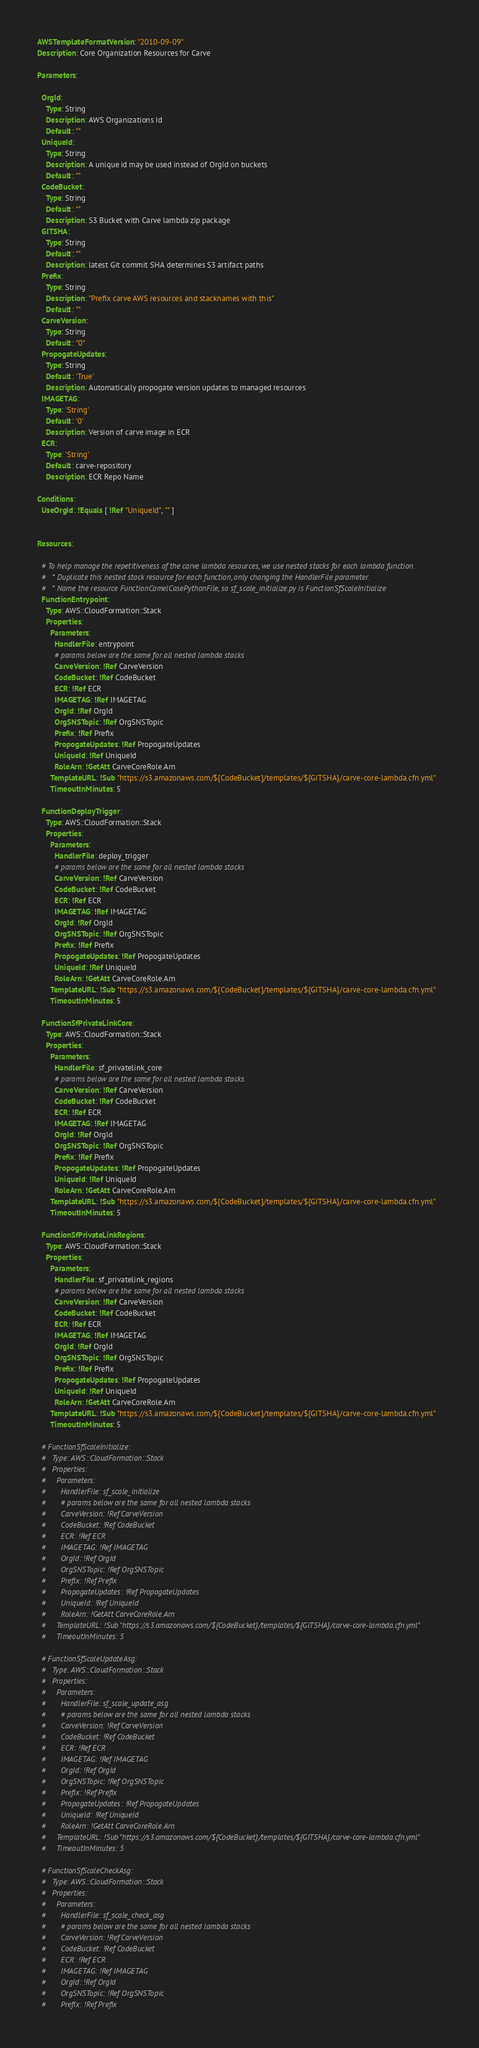<code> <loc_0><loc_0><loc_500><loc_500><_YAML_>AWSTemplateFormatVersion: "2010-09-09"
Description: Core Organization Resources for Carve

Parameters:
  
  OrgId:
    Type: String
    Description: AWS Organizations Id
    Default: ""
  UniqueId:
    Type: String
    Description: A unique id may be used instead of OrgId on buckets
    Default: ""
  CodeBucket:
    Type: String
    Default: ""
    Description: S3 Bucket with Carve lambda zip package
  GITSHA:
    Type: String
    Default: ""
    Description: latest Git commit SHA determines S3 artifact paths
  Prefix:
    Type: String
    Description: "Prefix carve AWS resources and stacknames with this"
    Default: ""
  CarveVersion:
    Type: String
    Default: "0"
  PropogateUpdates:
    Type: String
    Default: 'True'
    Description: Automatically propogate version updates to managed resources 
  IMAGETAG: 
    Type: 'String'
    Default: '0'
    Description: Version of carve image in ECR
  ECR:
    Type: 'String'
    Default: carve-repository
    Description: ECR Repo Name

Conditions:
  UseOrgId: !Equals [ !Ref "UniqueId", "" ]


Resources:

  # To help manage the repetitiveness of the carve lambda resources, we use nested stacks for each lambda function.
  #   * Duplicate this nested stack resource for each function, only changing the HandlerFile parameter.
  #   * Name the resource FunctionCamelCasePythonFile, so sf_scale_initialize.py is FunctionSfScaleInitialize
  FunctionEntrypoint:
    Type: AWS::CloudFormation::Stack
    Properties: 
      Parameters:
        HandlerFile: entrypoint
        # params below are the same for all nested lambda stacks
        CarveVersion: !Ref CarveVersion
        CodeBucket: !Ref CodeBucket
        ECR: !Ref ECR
        IMAGETAG: !Ref IMAGETAG
        OrgId: !Ref OrgId
        OrgSNSTopic: !Ref OrgSNSTopic
        Prefix: !Ref Prefix
        PropogateUpdates: !Ref PropogateUpdates
        UniqueId: !Ref UniqueId
        RoleArn: !GetAtt CarveCoreRole.Arn
      TemplateURL: !Sub "https://s3.amazonaws.com/${CodeBucket}/templates/${GITSHA}/carve-core-lambda.cfn.yml"
      TimeoutInMinutes: 5

  FunctionDeployTrigger:
    Type: AWS::CloudFormation::Stack
    Properties: 
      Parameters:
        HandlerFile: deploy_trigger
        # params below are the same for all nested lambda stacks
        CarveVersion: !Ref CarveVersion
        CodeBucket: !Ref CodeBucket
        ECR: !Ref ECR
        IMAGETAG: !Ref IMAGETAG
        OrgId: !Ref OrgId
        OrgSNSTopic: !Ref OrgSNSTopic
        Prefix: !Ref Prefix
        PropogateUpdates: !Ref PropogateUpdates
        UniqueId: !Ref UniqueId
        RoleArn: !GetAtt CarveCoreRole.Arn
      TemplateURL: !Sub "https://s3.amazonaws.com/${CodeBucket}/templates/${GITSHA}/carve-core-lambda.cfn.yml"
      TimeoutInMinutes: 5

  FunctionSfPrivateLinkCore:
    Type: AWS::CloudFormation::Stack
    Properties: 
      Parameters:
        HandlerFile: sf_privatelink_core
        # params below are the same for all nested lambda stacks
        CarveVersion: !Ref CarveVersion
        CodeBucket: !Ref CodeBucket
        ECR: !Ref ECR
        IMAGETAG: !Ref IMAGETAG
        OrgId: !Ref OrgId
        OrgSNSTopic: !Ref OrgSNSTopic
        Prefix: !Ref Prefix
        PropogateUpdates: !Ref PropogateUpdates
        UniqueId: !Ref UniqueId
        RoleArn: !GetAtt CarveCoreRole.Arn
      TemplateURL: !Sub "https://s3.amazonaws.com/${CodeBucket}/templates/${GITSHA}/carve-core-lambda.cfn.yml"
      TimeoutInMinutes: 5

  FunctionSfPrivateLinkRegions:
    Type: AWS::CloudFormation::Stack
    Properties: 
      Parameters:
        HandlerFile: sf_privatelink_regions
        # params below are the same for all nested lambda stacks
        CarveVersion: !Ref CarveVersion
        CodeBucket: !Ref CodeBucket
        ECR: !Ref ECR
        IMAGETAG: !Ref IMAGETAG
        OrgId: !Ref OrgId
        OrgSNSTopic: !Ref OrgSNSTopic
        Prefix: !Ref Prefix
        PropogateUpdates: !Ref PropogateUpdates
        UniqueId: !Ref UniqueId
        RoleArn: !GetAtt CarveCoreRole.Arn
      TemplateURL: !Sub "https://s3.amazonaws.com/${CodeBucket}/templates/${GITSHA}/carve-core-lambda.cfn.yml"
      TimeoutInMinutes: 5

  # FunctionSfScaleInitialize:
  #   Type: AWS::CloudFormation::Stack
  #   Properties: 
  #     Parameters:
  #       HandlerFile: sf_scale_initialize
  #       # params below are the same for all nested lambda stacks
  #       CarveVersion: !Ref CarveVersion
  #       CodeBucket: !Ref CodeBucket
  #       ECR: !Ref ECR
  #       IMAGETAG: !Ref IMAGETAG
  #       OrgId: !Ref OrgId
  #       OrgSNSTopic: !Ref OrgSNSTopic
  #       Prefix: !Ref Prefix
  #       PropogateUpdates: !Ref PropogateUpdates
  #       UniqueId: !Ref UniqueId
  #       RoleArn: !GetAtt CarveCoreRole.Arn
  #     TemplateURL: !Sub "https://s3.amazonaws.com/${CodeBucket}/templates/${GITSHA}/carve-core-lambda.cfn.yml"
  #     TimeoutInMinutes: 5

  # FunctionSfScaleUpdateAsg:
  #   Type: AWS::CloudFormation::Stack
  #   Properties: 
  #     Parameters:
  #       HandlerFile: sf_scale_update_asg
  #       # params below are the same for all nested lambda stacks
  #       CarveVersion: !Ref CarveVersion
  #       CodeBucket: !Ref CodeBucket
  #       ECR: !Ref ECR
  #       IMAGETAG: !Ref IMAGETAG
  #       OrgId: !Ref OrgId
  #       OrgSNSTopic: !Ref OrgSNSTopic
  #       Prefix: !Ref Prefix
  #       PropogateUpdates: !Ref PropogateUpdates
  #       UniqueId: !Ref UniqueId
  #       RoleArn: !GetAtt CarveCoreRole.Arn
  #     TemplateURL: !Sub "https://s3.amazonaws.com/${CodeBucket}/templates/${GITSHA}/carve-core-lambda.cfn.yml"
  #     TimeoutInMinutes: 5

  # FunctionSfScaleCheckAsg:
  #   Type: AWS::CloudFormation::Stack
  #   Properties: 
  #     Parameters:
  #       HandlerFile: sf_scale_check_asg
  #       # params below are the same for all nested lambda stacks
  #       CarveVersion: !Ref CarveVersion
  #       CodeBucket: !Ref CodeBucket
  #       ECR: !Ref ECR
  #       IMAGETAG: !Ref IMAGETAG
  #       OrgId: !Ref OrgId
  #       OrgSNSTopic: !Ref OrgSNSTopic
  #       Prefix: !Ref Prefix</code> 